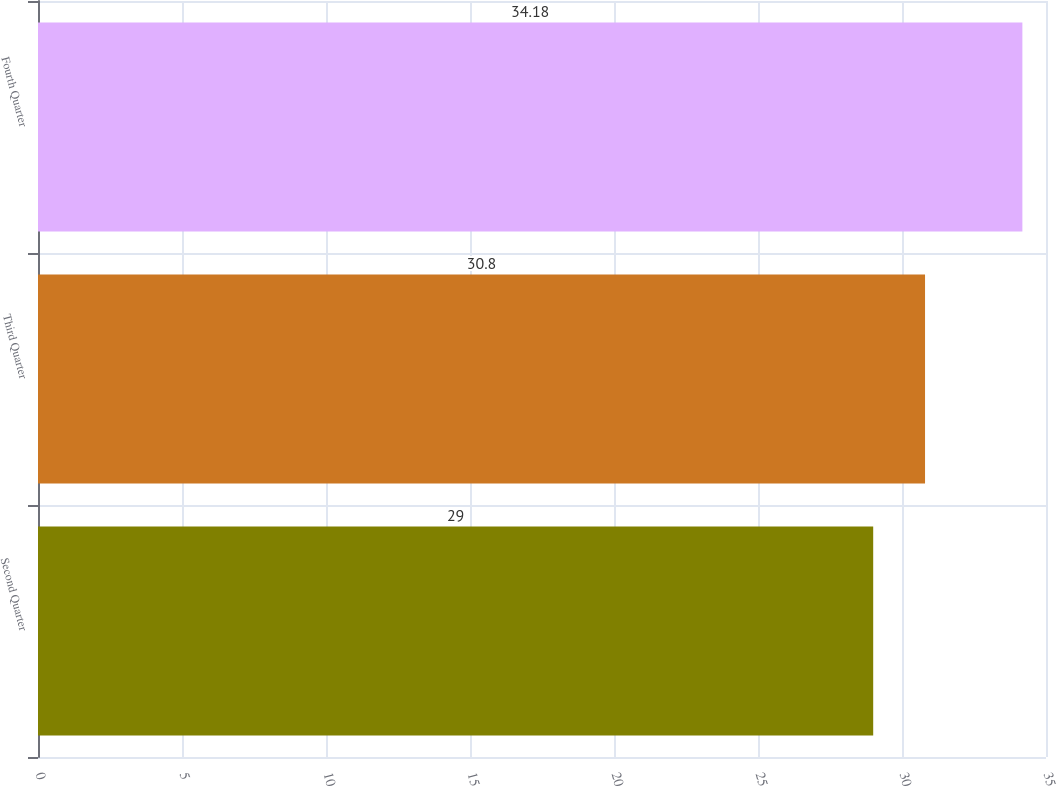Convert chart. <chart><loc_0><loc_0><loc_500><loc_500><bar_chart><fcel>Second Quarter<fcel>Third Quarter<fcel>Fourth Quarter<nl><fcel>29<fcel>30.8<fcel>34.18<nl></chart> 